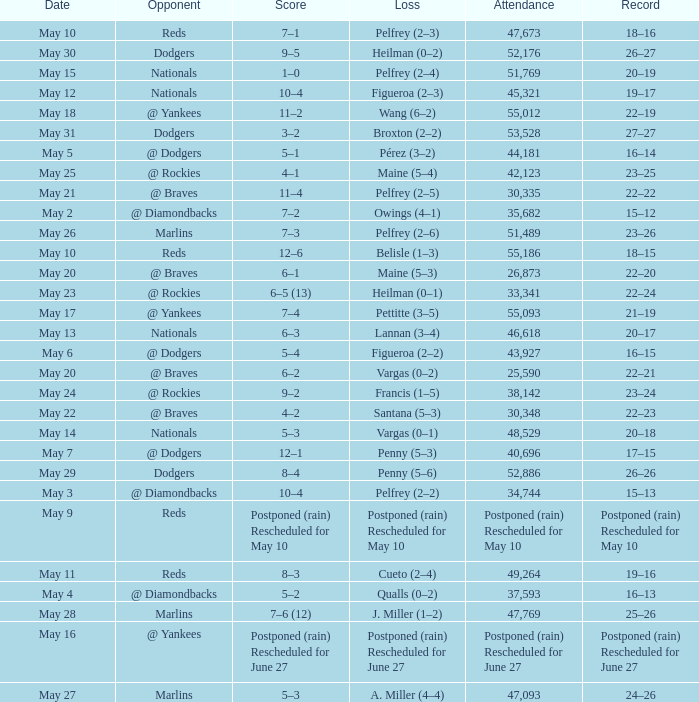Record of 22–20 involved what score? 6–1. 